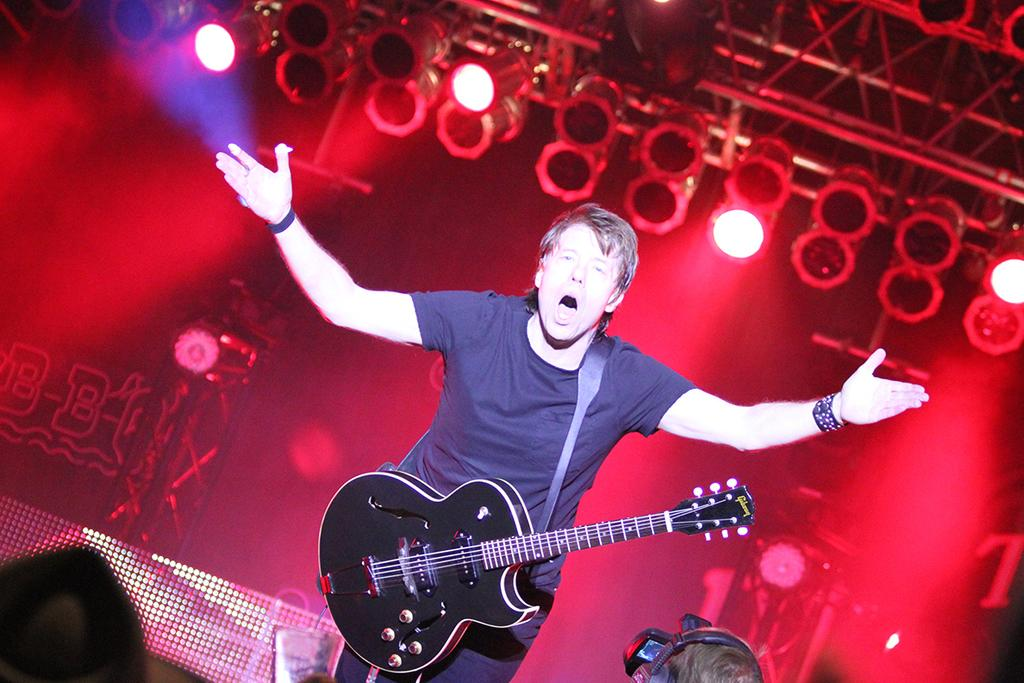What is the main subject of the image? There is a person in the image. What is the person doing in the image? The person is playing the guitar and singing. How would you describe the background of the image? The background of the image is dark. What is the profit made from the cream in the image? There is no mention of profit or cream in the image; it features a person playing the guitar and singing. 